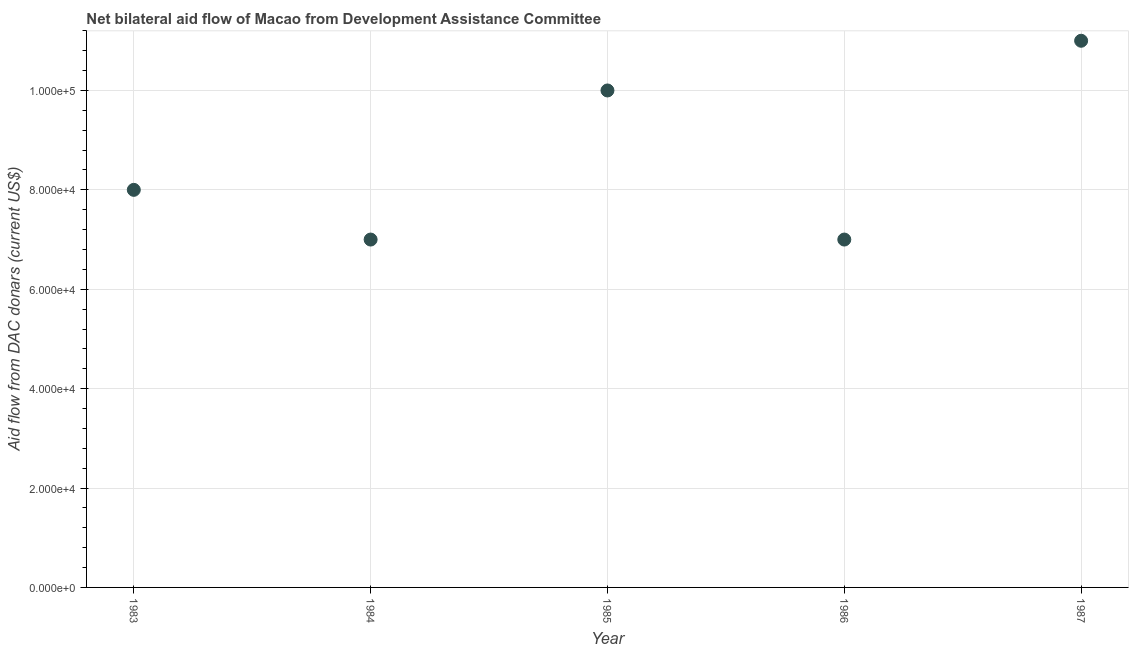What is the net bilateral aid flows from dac donors in 1983?
Keep it short and to the point. 8.00e+04. Across all years, what is the maximum net bilateral aid flows from dac donors?
Provide a short and direct response. 1.10e+05. Across all years, what is the minimum net bilateral aid flows from dac donors?
Your response must be concise. 7.00e+04. What is the sum of the net bilateral aid flows from dac donors?
Give a very brief answer. 4.30e+05. What is the difference between the net bilateral aid flows from dac donors in 1983 and 1986?
Offer a very short reply. 10000. What is the average net bilateral aid flows from dac donors per year?
Provide a succinct answer. 8.60e+04. What is the median net bilateral aid flows from dac donors?
Provide a short and direct response. 8.00e+04. Do a majority of the years between 1987 and 1985 (inclusive) have net bilateral aid flows from dac donors greater than 32000 US$?
Your answer should be compact. No. What is the ratio of the net bilateral aid flows from dac donors in 1985 to that in 1987?
Provide a succinct answer. 0.91. What is the difference between the highest and the second highest net bilateral aid flows from dac donors?
Offer a very short reply. 10000. Is the sum of the net bilateral aid flows from dac donors in 1983 and 1984 greater than the maximum net bilateral aid flows from dac donors across all years?
Your response must be concise. Yes. What is the difference between the highest and the lowest net bilateral aid flows from dac donors?
Your answer should be very brief. 4.00e+04. In how many years, is the net bilateral aid flows from dac donors greater than the average net bilateral aid flows from dac donors taken over all years?
Your answer should be very brief. 2. Does the net bilateral aid flows from dac donors monotonically increase over the years?
Offer a very short reply. No. What is the difference between two consecutive major ticks on the Y-axis?
Your answer should be compact. 2.00e+04. Are the values on the major ticks of Y-axis written in scientific E-notation?
Offer a very short reply. Yes. Does the graph contain grids?
Provide a succinct answer. Yes. What is the title of the graph?
Your answer should be compact. Net bilateral aid flow of Macao from Development Assistance Committee. What is the label or title of the X-axis?
Provide a succinct answer. Year. What is the label or title of the Y-axis?
Ensure brevity in your answer.  Aid flow from DAC donars (current US$). What is the Aid flow from DAC donars (current US$) in 1983?
Give a very brief answer. 8.00e+04. What is the difference between the Aid flow from DAC donars (current US$) in 1983 and 1984?
Offer a terse response. 10000. What is the difference between the Aid flow from DAC donars (current US$) in 1983 and 1985?
Make the answer very short. -2.00e+04. What is the difference between the Aid flow from DAC donars (current US$) in 1983 and 1986?
Offer a very short reply. 10000. What is the difference between the Aid flow from DAC donars (current US$) in 1983 and 1987?
Keep it short and to the point. -3.00e+04. What is the difference between the Aid flow from DAC donars (current US$) in 1984 and 1985?
Provide a succinct answer. -3.00e+04. What is the difference between the Aid flow from DAC donars (current US$) in 1985 and 1986?
Offer a terse response. 3.00e+04. What is the ratio of the Aid flow from DAC donars (current US$) in 1983 to that in 1984?
Offer a terse response. 1.14. What is the ratio of the Aid flow from DAC donars (current US$) in 1983 to that in 1985?
Your answer should be very brief. 0.8. What is the ratio of the Aid flow from DAC donars (current US$) in 1983 to that in 1986?
Offer a terse response. 1.14. What is the ratio of the Aid flow from DAC donars (current US$) in 1983 to that in 1987?
Offer a terse response. 0.73. What is the ratio of the Aid flow from DAC donars (current US$) in 1984 to that in 1985?
Give a very brief answer. 0.7. What is the ratio of the Aid flow from DAC donars (current US$) in 1984 to that in 1986?
Offer a very short reply. 1. What is the ratio of the Aid flow from DAC donars (current US$) in 1984 to that in 1987?
Provide a succinct answer. 0.64. What is the ratio of the Aid flow from DAC donars (current US$) in 1985 to that in 1986?
Provide a short and direct response. 1.43. What is the ratio of the Aid flow from DAC donars (current US$) in 1985 to that in 1987?
Offer a very short reply. 0.91. What is the ratio of the Aid flow from DAC donars (current US$) in 1986 to that in 1987?
Offer a terse response. 0.64. 